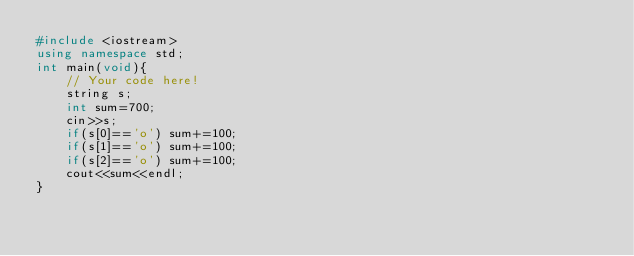<code> <loc_0><loc_0><loc_500><loc_500><_C++_>#include <iostream>
using namespace std;
int main(void){
    // Your code here!
    string s;
    int sum=700;
    cin>>s;
    if(s[0]=='o') sum+=100;
    if(s[1]=='o') sum+=100;
    if(s[2]=='o') sum+=100;
    cout<<sum<<endl;
}
</code> 